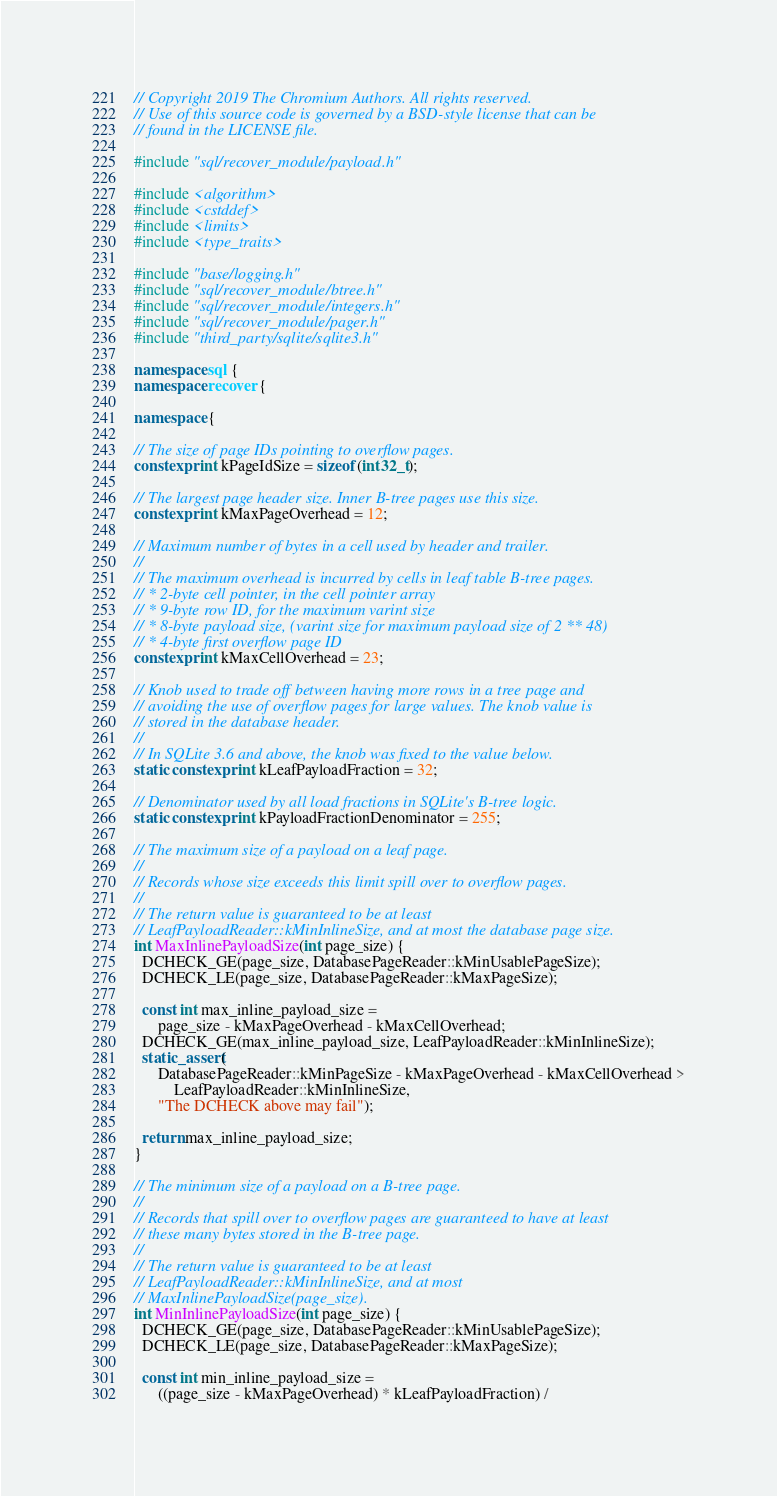<code> <loc_0><loc_0><loc_500><loc_500><_C++_>
// Copyright 2019 The Chromium Authors. All rights reserved.
// Use of this source code is governed by a BSD-style license that can be
// found in the LICENSE file.

#include "sql/recover_module/payload.h"

#include <algorithm>
#include <cstddef>
#include <limits>
#include <type_traits>

#include "base/logging.h"
#include "sql/recover_module/btree.h"
#include "sql/recover_module/integers.h"
#include "sql/recover_module/pager.h"
#include "third_party/sqlite/sqlite3.h"

namespace sql {
namespace recover {

namespace {

// The size of page IDs pointing to overflow pages.
constexpr int kPageIdSize = sizeof(int32_t);

// The largest page header size. Inner B-tree pages use this size.
constexpr int kMaxPageOverhead = 12;

// Maximum number of bytes in a cell used by header and trailer.
//
// The maximum overhead is incurred by cells in leaf table B-tree pages.
// * 2-byte cell pointer, in the cell pointer array
// * 9-byte row ID, for the maximum varint size
// * 8-byte payload size, (varint size for maximum payload size of 2 ** 48)
// * 4-byte first overflow page ID
constexpr int kMaxCellOverhead = 23;

// Knob used to trade off between having more rows in a tree page and
// avoiding the use of overflow pages for large values. The knob value is
// stored in the database header.
//
// In SQLite 3.6 and above, the knob was fixed to the value below.
static constexpr int kLeafPayloadFraction = 32;

// Denominator used by all load fractions in SQLite's B-tree logic.
static constexpr int kPayloadFractionDenominator = 255;

// The maximum size of a payload on a leaf page.
//
// Records whose size exceeds this limit spill over to overflow pages.
//
// The return value is guaranteed to be at least
// LeafPayloadReader::kMinInlineSize, and at most the database page size.
int MaxInlinePayloadSize(int page_size) {
  DCHECK_GE(page_size, DatabasePageReader::kMinUsablePageSize);
  DCHECK_LE(page_size, DatabasePageReader::kMaxPageSize);

  const int max_inline_payload_size =
      page_size - kMaxPageOverhead - kMaxCellOverhead;
  DCHECK_GE(max_inline_payload_size, LeafPayloadReader::kMinInlineSize);
  static_assert(
      DatabasePageReader::kMinPageSize - kMaxPageOverhead - kMaxCellOverhead >
          LeafPayloadReader::kMinInlineSize,
      "The DCHECK above may fail");

  return max_inline_payload_size;
}

// The minimum size of a payload on a B-tree page.
//
// Records that spill over to overflow pages are guaranteed to have at least
// these many bytes stored in the B-tree page.
//
// The return value is guaranteed to be at least
// LeafPayloadReader::kMinInlineSize, and at most
// MaxInlinePayloadSize(page_size).
int MinInlinePayloadSize(int page_size) {
  DCHECK_GE(page_size, DatabasePageReader::kMinUsablePageSize);
  DCHECK_LE(page_size, DatabasePageReader::kMaxPageSize);

  const int min_inline_payload_size =
      ((page_size - kMaxPageOverhead) * kLeafPayloadFraction) /</code> 